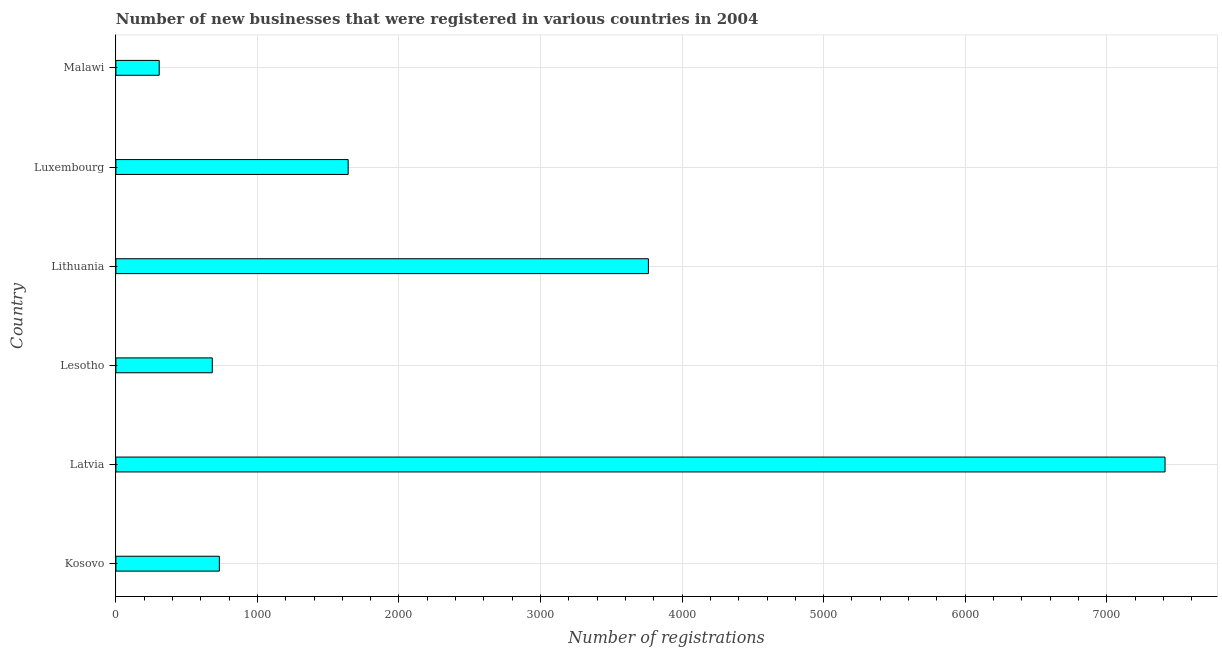Does the graph contain any zero values?
Offer a terse response. No. What is the title of the graph?
Your answer should be very brief. Number of new businesses that were registered in various countries in 2004. What is the label or title of the X-axis?
Your answer should be very brief. Number of registrations. What is the number of new business registrations in Malawi?
Give a very brief answer. 306. Across all countries, what is the maximum number of new business registrations?
Your response must be concise. 7412. Across all countries, what is the minimum number of new business registrations?
Offer a very short reply. 306. In which country was the number of new business registrations maximum?
Your answer should be compact. Latvia. In which country was the number of new business registrations minimum?
Give a very brief answer. Malawi. What is the sum of the number of new business registrations?
Offer a terse response. 1.45e+04. What is the difference between the number of new business registrations in Kosovo and Latvia?
Provide a short and direct response. -6681. What is the average number of new business registrations per country?
Offer a terse response. 2422. What is the median number of new business registrations?
Your response must be concise. 1186. In how many countries, is the number of new business registrations greater than 3600 ?
Your response must be concise. 2. What is the ratio of the number of new business registrations in Lesotho to that in Lithuania?
Provide a short and direct response. 0.18. Is the number of new business registrations in Kosovo less than that in Latvia?
Your answer should be very brief. Yes. Is the difference between the number of new business registrations in Kosovo and Lesotho greater than the difference between any two countries?
Provide a short and direct response. No. What is the difference between the highest and the second highest number of new business registrations?
Offer a very short reply. 3650. Is the sum of the number of new business registrations in Lesotho and Luxembourg greater than the maximum number of new business registrations across all countries?
Offer a terse response. No. What is the difference between the highest and the lowest number of new business registrations?
Your answer should be very brief. 7106. How many bars are there?
Ensure brevity in your answer.  6. How many countries are there in the graph?
Your response must be concise. 6. What is the difference between two consecutive major ticks on the X-axis?
Make the answer very short. 1000. Are the values on the major ticks of X-axis written in scientific E-notation?
Make the answer very short. No. What is the Number of registrations of Kosovo?
Offer a very short reply. 731. What is the Number of registrations in Latvia?
Offer a very short reply. 7412. What is the Number of registrations of Lesotho?
Your answer should be very brief. 681. What is the Number of registrations in Lithuania?
Your answer should be compact. 3762. What is the Number of registrations in Luxembourg?
Your answer should be very brief. 1641. What is the Number of registrations in Malawi?
Give a very brief answer. 306. What is the difference between the Number of registrations in Kosovo and Latvia?
Provide a short and direct response. -6681. What is the difference between the Number of registrations in Kosovo and Lithuania?
Make the answer very short. -3031. What is the difference between the Number of registrations in Kosovo and Luxembourg?
Your answer should be compact. -910. What is the difference between the Number of registrations in Kosovo and Malawi?
Your answer should be very brief. 425. What is the difference between the Number of registrations in Latvia and Lesotho?
Keep it short and to the point. 6731. What is the difference between the Number of registrations in Latvia and Lithuania?
Your answer should be compact. 3650. What is the difference between the Number of registrations in Latvia and Luxembourg?
Offer a very short reply. 5771. What is the difference between the Number of registrations in Latvia and Malawi?
Your response must be concise. 7106. What is the difference between the Number of registrations in Lesotho and Lithuania?
Provide a succinct answer. -3081. What is the difference between the Number of registrations in Lesotho and Luxembourg?
Provide a succinct answer. -960. What is the difference between the Number of registrations in Lesotho and Malawi?
Provide a succinct answer. 375. What is the difference between the Number of registrations in Lithuania and Luxembourg?
Your answer should be very brief. 2121. What is the difference between the Number of registrations in Lithuania and Malawi?
Offer a terse response. 3456. What is the difference between the Number of registrations in Luxembourg and Malawi?
Ensure brevity in your answer.  1335. What is the ratio of the Number of registrations in Kosovo to that in Latvia?
Make the answer very short. 0.1. What is the ratio of the Number of registrations in Kosovo to that in Lesotho?
Keep it short and to the point. 1.07. What is the ratio of the Number of registrations in Kosovo to that in Lithuania?
Make the answer very short. 0.19. What is the ratio of the Number of registrations in Kosovo to that in Luxembourg?
Ensure brevity in your answer.  0.45. What is the ratio of the Number of registrations in Kosovo to that in Malawi?
Your answer should be very brief. 2.39. What is the ratio of the Number of registrations in Latvia to that in Lesotho?
Your answer should be very brief. 10.88. What is the ratio of the Number of registrations in Latvia to that in Lithuania?
Provide a short and direct response. 1.97. What is the ratio of the Number of registrations in Latvia to that in Luxembourg?
Ensure brevity in your answer.  4.52. What is the ratio of the Number of registrations in Latvia to that in Malawi?
Offer a very short reply. 24.22. What is the ratio of the Number of registrations in Lesotho to that in Lithuania?
Make the answer very short. 0.18. What is the ratio of the Number of registrations in Lesotho to that in Luxembourg?
Provide a succinct answer. 0.41. What is the ratio of the Number of registrations in Lesotho to that in Malawi?
Keep it short and to the point. 2.23. What is the ratio of the Number of registrations in Lithuania to that in Luxembourg?
Give a very brief answer. 2.29. What is the ratio of the Number of registrations in Lithuania to that in Malawi?
Offer a very short reply. 12.29. What is the ratio of the Number of registrations in Luxembourg to that in Malawi?
Offer a terse response. 5.36. 